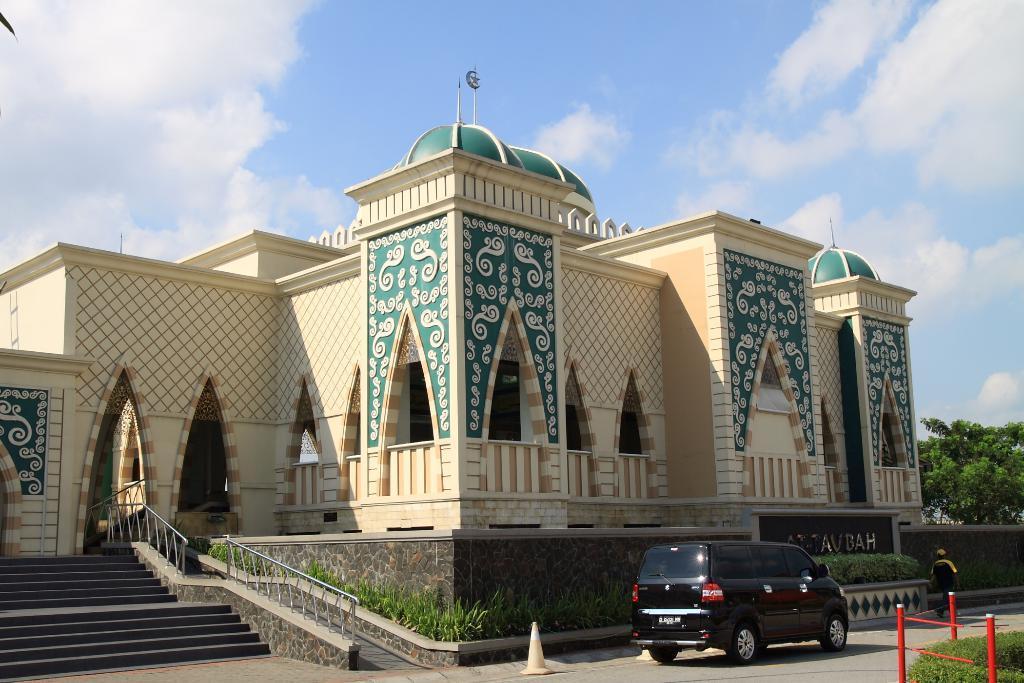How would you summarize this image in a sentence or two? In this image there is a building in the middle. At the top there is the sky. At the bottom there is a car on the road. On the left side there are steps. Beside the steps there are small plants around the wall. On the right side there are trees. At the bottom there is a metal fence. 